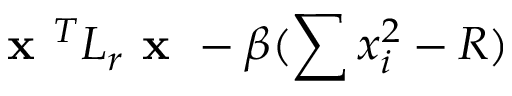Convert formula to latex. <formula><loc_0><loc_0><loc_500><loc_500>x ^ { T } L _ { r } x - \beta ( \sum x _ { i } ^ { 2 } - R )</formula> 